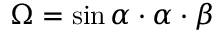Convert formula to latex. <formula><loc_0><loc_0><loc_500><loc_500>\Omega = \sin \alpha \cdot \alpha \cdot \beta</formula> 